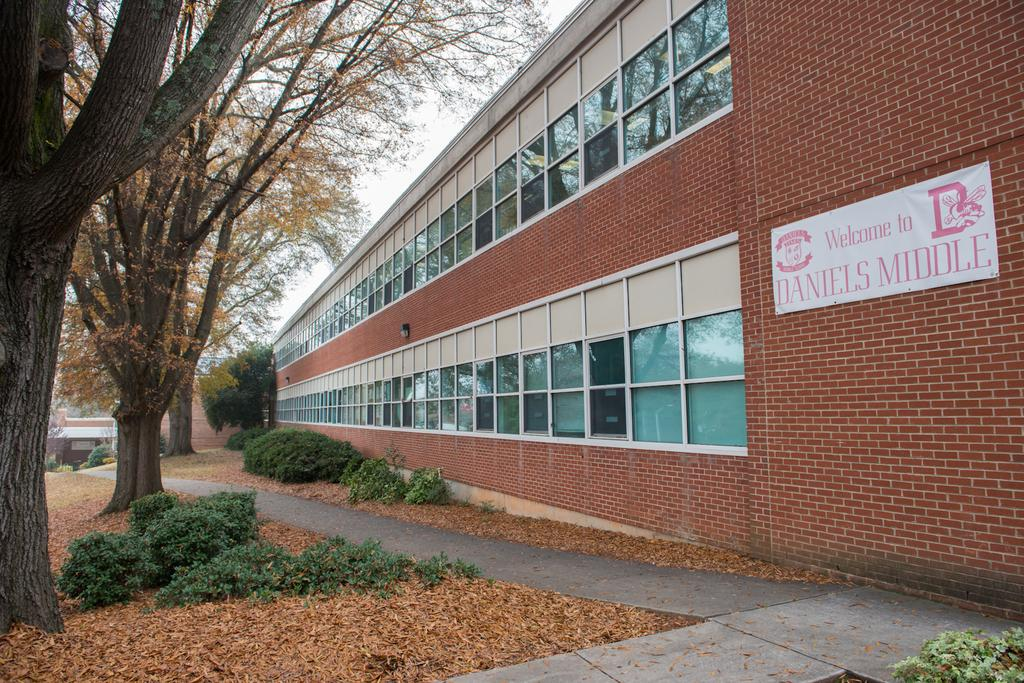What type of natural material can be seen in the image? There are dried leaves in the image. What else is present on the ground in the image? There are plants on the ground in the image. What structures can be seen in the background of the image? There is a building and a shed in the background of the image. What type of vegetation is visible in the background of the image? There are trees in the background of the image. What part of the natural environment is visible in the background of the image? The sky is visible in the background of the image. Can you hear the sound of someone laughing in the image? There is no sound or indication of laughter in the image; it is a still image. 